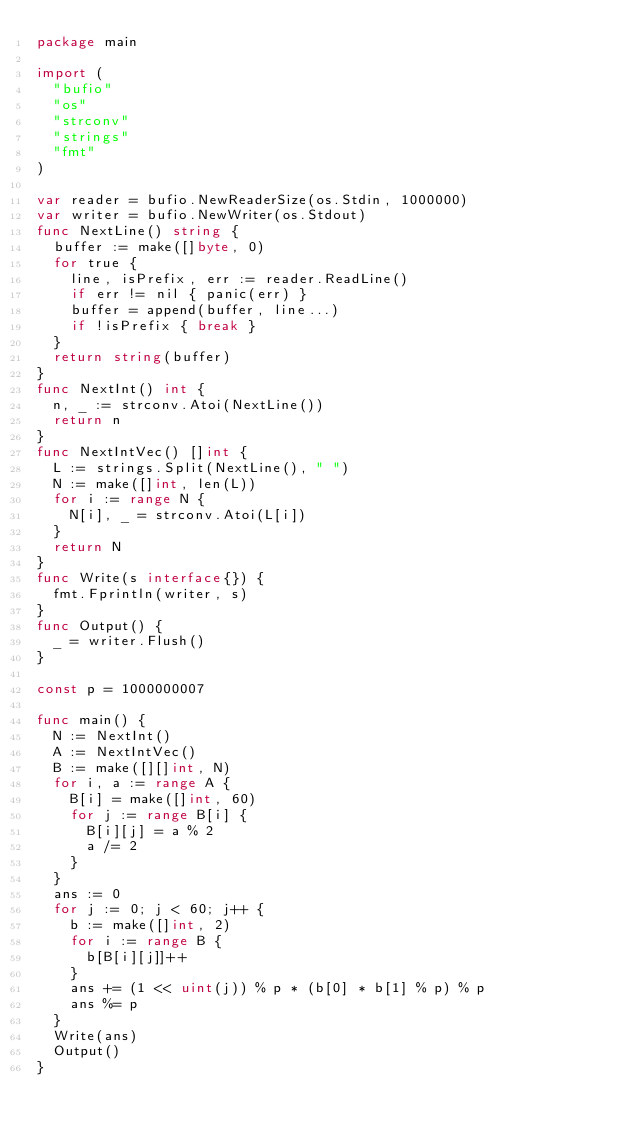Convert code to text. <code><loc_0><loc_0><loc_500><loc_500><_Go_>package main

import (
  "bufio"
  "os"
  "strconv"
  "strings"
  "fmt"
)

var reader = bufio.NewReaderSize(os.Stdin, 1000000)
var writer = bufio.NewWriter(os.Stdout)
func NextLine() string {
  buffer := make([]byte, 0)
  for true {
    line, isPrefix, err := reader.ReadLine()
    if err != nil { panic(err) }
    buffer = append(buffer, line...)
    if !isPrefix { break }
  }
  return string(buffer)
}
func NextInt() int {
  n, _ := strconv.Atoi(NextLine())
  return n
}
func NextIntVec() []int {
  L := strings.Split(NextLine(), " ")
  N := make([]int, len(L))
  for i := range N {
    N[i], _ = strconv.Atoi(L[i])
  }
  return N
}
func Write(s interface{}) {
  fmt.Fprintln(writer, s)
}
func Output() {
  _ = writer.Flush()
}

const p = 1000000007

func main() {
  N := NextInt()
  A := NextIntVec()
  B := make([][]int, N)
  for i, a := range A {
    B[i] = make([]int, 60)
    for j := range B[i] {
      B[i][j] = a % 2
      a /= 2
    }
  }
  ans := 0
  for j := 0; j < 60; j++ {
    b := make([]int, 2)
    for i := range B {
      b[B[i][j]]++
    }
    ans += (1 << uint(j)) % p * (b[0] * b[1] % p) % p
    ans %= p
  }
  Write(ans)
  Output()
}</code> 